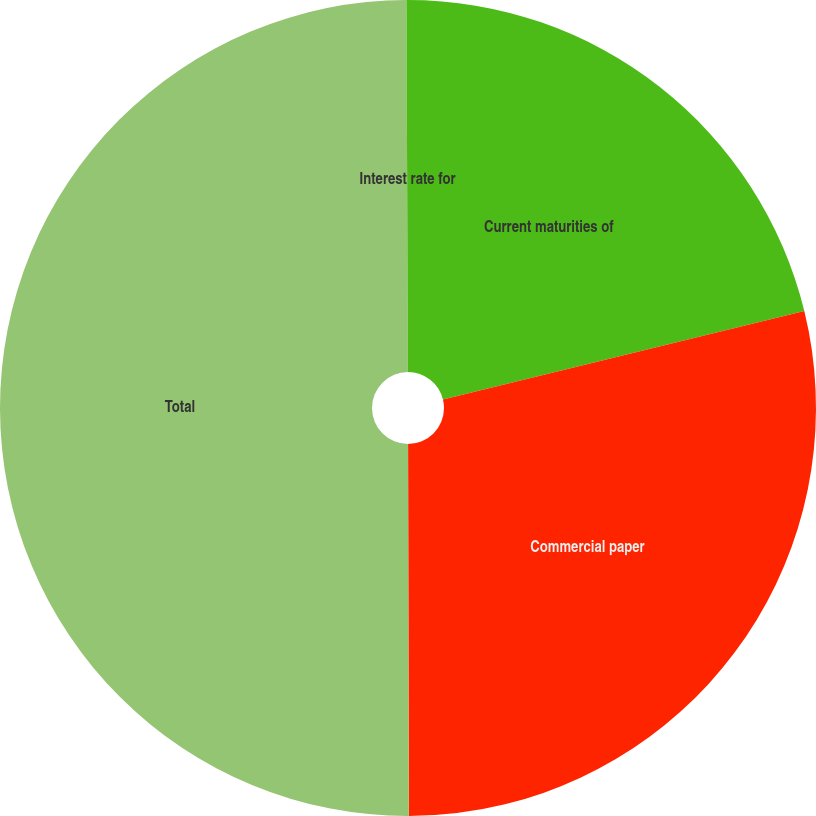Convert chart. <chart><loc_0><loc_0><loc_500><loc_500><pie_chart><fcel>Current maturities of<fcel>Commercial paper<fcel>Total<fcel>Interest rate for<nl><fcel>21.18%<fcel>28.79%<fcel>49.97%<fcel>0.06%<nl></chart> 